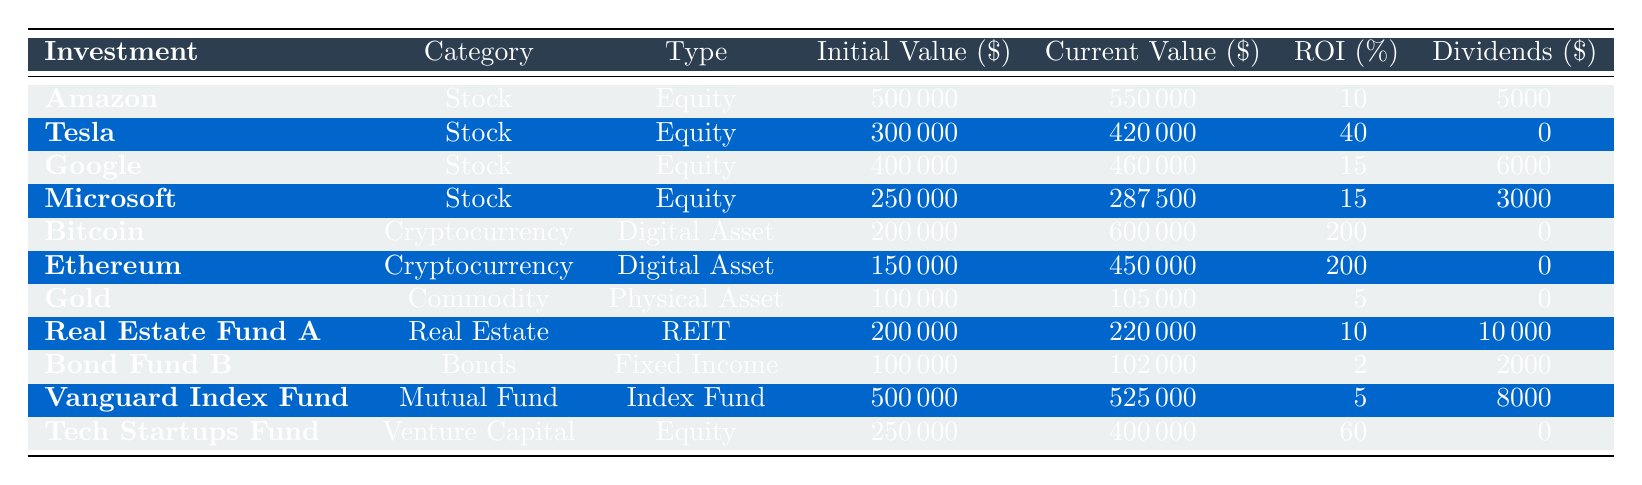What is the initial value of the investment in Bitcoin? The table shows that the initial value of the investment in Bitcoin is listed under the "Initial Value ($)" column for Bitcoin, which is 200000.
Answer: 200000 What is the current value of Real Estate Fund A? The "Current Value ($)" column indicates that for Real Estate Fund A, the current value is 220000.
Answer: 220000 Which investment has the highest ROI percentage? By comparing the "ROI (%)" values in the table, Bitcoin and Ethereum both have the highest ROI percentage, which is 200.
Answer: 200 What is the total dividends received from investments that provided dividends? To find the total dividends, I add the dividends from each relevant investment: 5000 (Amazon) + 6000 (Google) + 3000 (Microsoft) + 10000 (Real Estate Fund A) + 2000 (Bond Fund B) + 8000 (Vanguard Index Fund) = 35000.
Answer: 35000 Is there any investment in cryptocurrency that paid dividends? Reviewing the "Dividends ($)" column for cryptocurrency investments (Bitcoin and Ethereum), both have a dividend value of 0, meaning they did not pay dividends.
Answer: No Which category has the largest initial investment and what is that amount? The largest initial investment can be found by comparing the "Initial Value ($)" in each category. The largest is the Investment in Amazon with an initial value of 500000.
Answer: 500000 What is the average current value of all technology company stock investments? Identify stock investments: Amazon (550000), Tesla (420000), Google (460000), Microsoft (287500). Sum: 550000 + 420000 + 460000 + 287500 = 1712500, and there's 4 investments, so average = 1712500 / 4 = 428125.
Answer: 428125 Do all investments in the category "Bonds" have a ROI percentage higher than 2? There is only one investment listed in the Bonds category, which is Bond Fund B, and its ROI percentage is exactly 2. So not all have a percentage above 2.
Answer: No What is the difference in current value between the highest and lowest valued equity investments? Highest equity investment: Tesla at 420000. Lowest equity investment: Microsoft at 287500. The difference is 420000 - 287500 = 132500.
Answer: 132500 